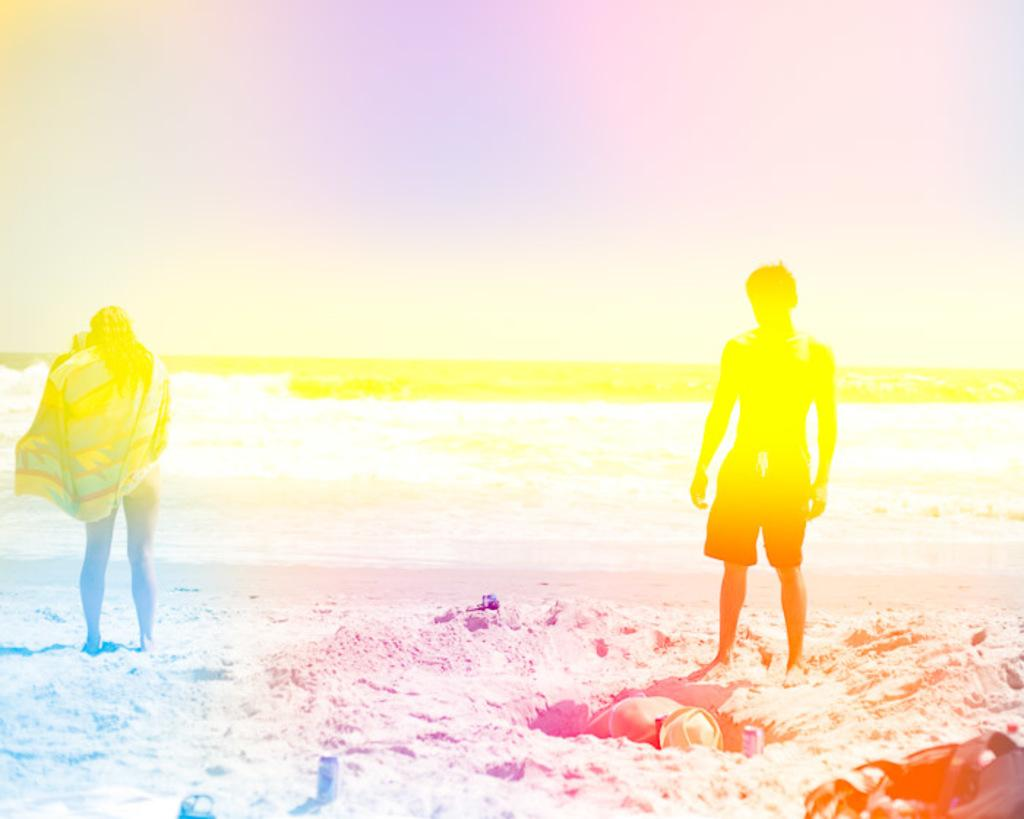What is the location of the persons in the image? The persons are standing on the seashore. What items can be seen with the persons in the image? There are backpacks and hats visible in the image. What type of beverage containers are present in the image? There are beverage tins in the image. What natural feature can be seen in the background of the image? The sea is visible in the image. What else is visible in the background of the image? The sky is visible in the image. What type of notebook is being used by the persons in the image? There is no notebook present in the image. What type of ring can be seen on the finger of the person in the image? There is no ring visible on any person's finger in the image. 